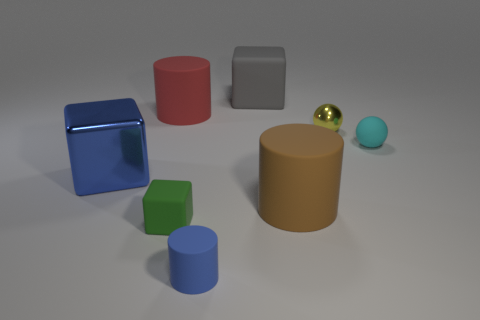How many rubber things are both in front of the gray rubber thing and to the left of the small yellow metallic sphere?
Provide a short and direct response. 4. There is a green object that is made of the same material as the cyan object; what size is it?
Keep it short and to the point. Small. What number of other metal objects have the same shape as the gray thing?
Give a very brief answer. 1. Are there more tiny matte things that are behind the green rubber cube than large blue metallic objects?
Give a very brief answer. No. What is the shape of the large rubber thing that is both behind the shiny ball and right of the small blue rubber cylinder?
Offer a terse response. Cube. Is the size of the brown matte object the same as the red rubber object?
Offer a terse response. Yes. There is a large gray block; what number of matte objects are on the left side of it?
Offer a very short reply. 3. Are there an equal number of blue cylinders that are behind the blue shiny thing and tiny green rubber objects that are behind the big red matte thing?
Keep it short and to the point. Yes. Does the metal object that is in front of the tiny yellow sphere have the same shape as the brown matte object?
Keep it short and to the point. No. Is there anything else that is the same material as the red object?
Offer a very short reply. Yes. 